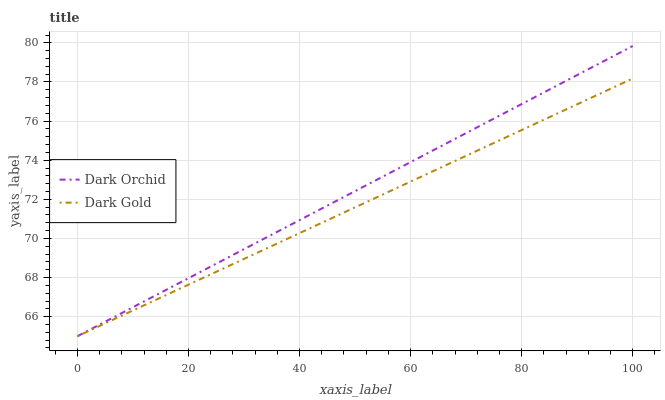Does Dark Gold have the minimum area under the curve?
Answer yes or no. Yes. Does Dark Orchid have the maximum area under the curve?
Answer yes or no. Yes. Does Dark Gold have the maximum area under the curve?
Answer yes or no. No. Is Dark Orchid the smoothest?
Answer yes or no. Yes. Is Dark Gold the roughest?
Answer yes or no. Yes. Is Dark Gold the smoothest?
Answer yes or no. No. Does Dark Orchid have the lowest value?
Answer yes or no. Yes. Does Dark Orchid have the highest value?
Answer yes or no. Yes. Does Dark Gold have the highest value?
Answer yes or no. No. Does Dark Gold intersect Dark Orchid?
Answer yes or no. Yes. Is Dark Gold less than Dark Orchid?
Answer yes or no. No. Is Dark Gold greater than Dark Orchid?
Answer yes or no. No. 